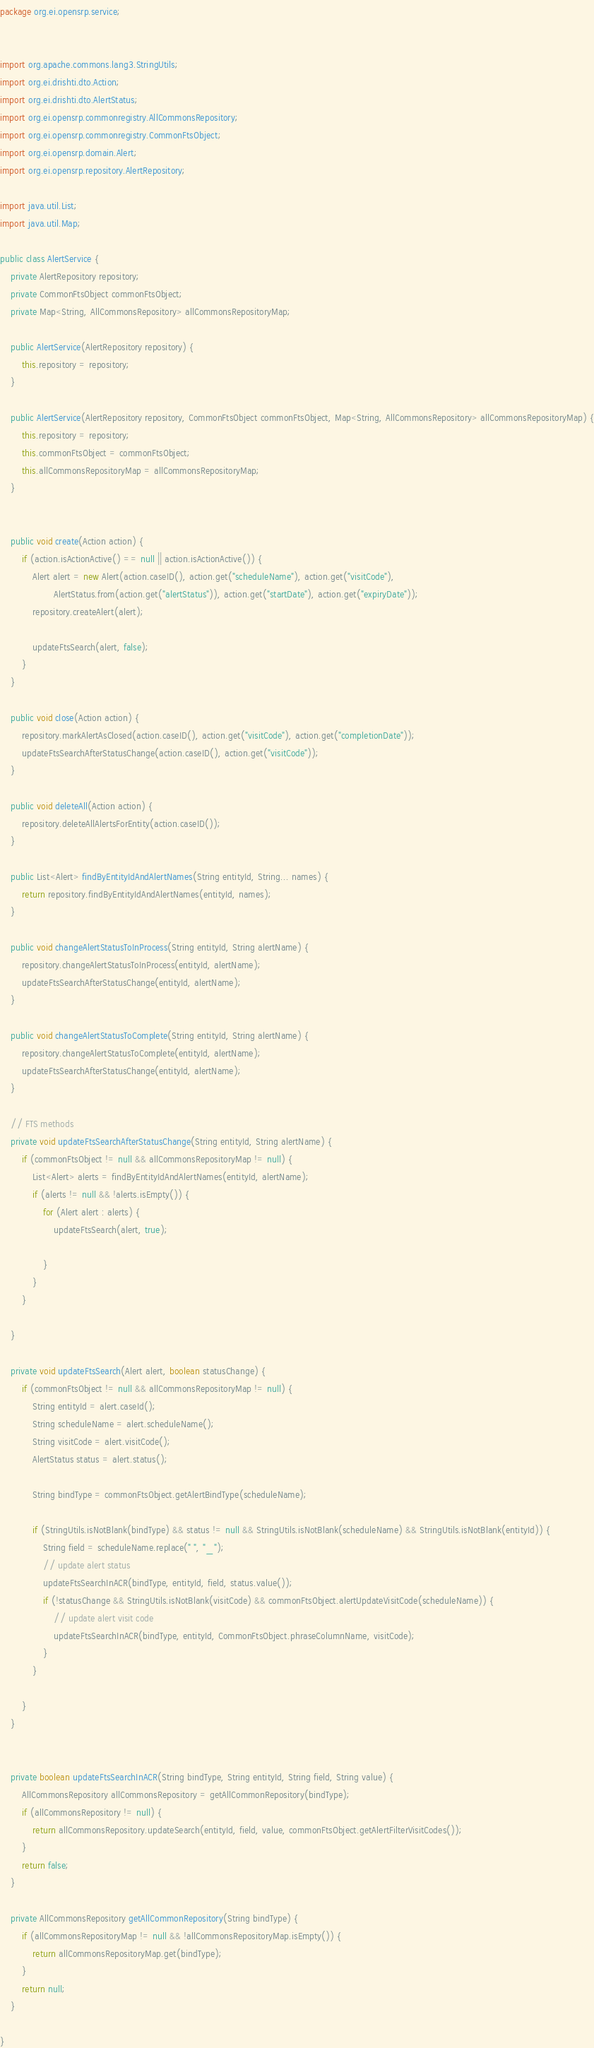Convert code to text. <code><loc_0><loc_0><loc_500><loc_500><_Java_>package org.ei.opensrp.service;


import org.apache.commons.lang3.StringUtils;
import org.ei.drishti.dto.Action;
import org.ei.drishti.dto.AlertStatus;
import org.ei.opensrp.commonregistry.AllCommonsRepository;
import org.ei.opensrp.commonregistry.CommonFtsObject;
import org.ei.opensrp.domain.Alert;
import org.ei.opensrp.repository.AlertRepository;

import java.util.List;
import java.util.Map;

public class AlertService {
    private AlertRepository repository;
    private CommonFtsObject commonFtsObject;
    private Map<String, AllCommonsRepository> allCommonsRepositoryMap;

    public AlertService(AlertRepository repository) {
        this.repository = repository;
    }

    public AlertService(AlertRepository repository, CommonFtsObject commonFtsObject, Map<String, AllCommonsRepository> allCommonsRepositoryMap) {
        this.repository = repository;
        this.commonFtsObject = commonFtsObject;
        this.allCommonsRepositoryMap = allCommonsRepositoryMap;
    }


    public void create(Action action) {
        if (action.isActionActive() == null || action.isActionActive()) {
            Alert alert = new Alert(action.caseID(), action.get("scheduleName"), action.get("visitCode"),
                    AlertStatus.from(action.get("alertStatus")), action.get("startDate"), action.get("expiryDate"));
            repository.createAlert(alert);

            updateFtsSearch(alert, false);
        }
    }

    public void close(Action action) {
        repository.markAlertAsClosed(action.caseID(), action.get("visitCode"), action.get("completionDate"));
        updateFtsSearchAfterStatusChange(action.caseID(), action.get("visitCode"));
    }

    public void deleteAll(Action action) {
        repository.deleteAllAlertsForEntity(action.caseID());
    }

    public List<Alert> findByEntityIdAndAlertNames(String entityId, String... names) {
        return repository.findByEntityIdAndAlertNames(entityId, names);
    }

    public void changeAlertStatusToInProcess(String entityId, String alertName) {
        repository.changeAlertStatusToInProcess(entityId, alertName);
        updateFtsSearchAfterStatusChange(entityId, alertName);
    }

    public void changeAlertStatusToComplete(String entityId, String alertName) {
        repository.changeAlertStatusToComplete(entityId, alertName);
        updateFtsSearchAfterStatusChange(entityId, alertName);
    }

    // FTS methods
    private void updateFtsSearchAfterStatusChange(String entityId, String alertName) {
        if (commonFtsObject != null && allCommonsRepositoryMap != null) {
            List<Alert> alerts = findByEntityIdAndAlertNames(entityId, alertName);
            if (alerts != null && !alerts.isEmpty()) {
                for (Alert alert : alerts) {
                    updateFtsSearch(alert, true);

                }
            }
        }

    }

    private void updateFtsSearch(Alert alert, boolean statusChange) {
        if (commonFtsObject != null && allCommonsRepositoryMap != null) {
            String entityId = alert.caseId();
            String scheduleName = alert.scheduleName();
            String visitCode = alert.visitCode();
            AlertStatus status = alert.status();

            String bindType = commonFtsObject.getAlertBindType(scheduleName);

            if (StringUtils.isNotBlank(bindType) && status != null && StringUtils.isNotBlank(scheduleName) && StringUtils.isNotBlank(entityId)) {
                String field = scheduleName.replace(" ", "_");
                // update alert status
                updateFtsSearchInACR(bindType, entityId, field, status.value());
                if (!statusChange && StringUtils.isNotBlank(visitCode) && commonFtsObject.alertUpdateVisitCode(scheduleName)) {
                    // update alert visit code
                    updateFtsSearchInACR(bindType, entityId, CommonFtsObject.phraseColumnName, visitCode);
                }
            }

        }
    }


    private boolean updateFtsSearchInACR(String bindType, String entityId, String field, String value) {
        AllCommonsRepository allCommonsRepository = getAllCommonRepository(bindType);
        if (allCommonsRepository != null) {
            return allCommonsRepository.updateSearch(entityId, field, value, commonFtsObject.getAlertFilterVisitCodes());
        }
        return false;
    }

    private AllCommonsRepository getAllCommonRepository(String bindType) {
        if (allCommonsRepositoryMap != null && !allCommonsRepositoryMap.isEmpty()) {
            return allCommonsRepositoryMap.get(bindType);
        }
        return null;
    }

}
</code> 